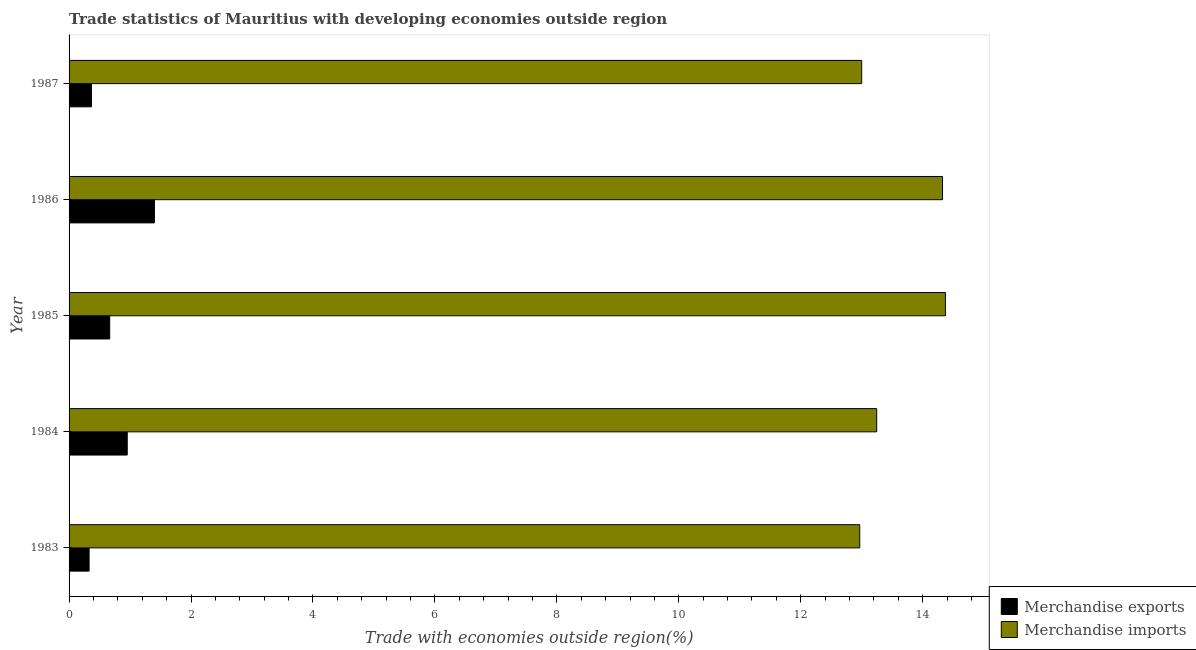How many different coloured bars are there?
Keep it short and to the point. 2. How many groups of bars are there?
Ensure brevity in your answer.  5. Are the number of bars per tick equal to the number of legend labels?
Make the answer very short. Yes. How many bars are there on the 4th tick from the top?
Offer a very short reply. 2. What is the label of the 2nd group of bars from the top?
Keep it short and to the point. 1986. What is the merchandise imports in 1987?
Offer a very short reply. 13. Across all years, what is the maximum merchandise imports?
Your response must be concise. 14.37. Across all years, what is the minimum merchandise imports?
Provide a succinct answer. 12.97. In which year was the merchandise imports maximum?
Ensure brevity in your answer.  1985. In which year was the merchandise exports minimum?
Your answer should be compact. 1983. What is the total merchandise imports in the graph?
Your answer should be very brief. 67.91. What is the difference between the merchandise imports in 1983 and that in 1985?
Your answer should be very brief. -1.41. What is the difference between the merchandise exports in 1987 and the merchandise imports in 1986?
Provide a succinct answer. -13.96. What is the average merchandise exports per year?
Provide a succinct answer. 0.74. In the year 1984, what is the difference between the merchandise imports and merchandise exports?
Your answer should be compact. 12.29. What is the ratio of the merchandise imports in 1985 to that in 1987?
Offer a very short reply. 1.11. Is the merchandise exports in 1986 less than that in 1987?
Provide a short and direct response. No. What is the difference between the highest and the second highest merchandise exports?
Offer a terse response. 0.45. What is the difference between the highest and the lowest merchandise exports?
Your answer should be compact. 1.07. Is the sum of the merchandise imports in 1984 and 1985 greater than the maximum merchandise exports across all years?
Provide a short and direct response. Yes. What does the 1st bar from the top in 1984 represents?
Your answer should be compact. Merchandise imports. Are all the bars in the graph horizontal?
Offer a very short reply. Yes. Are the values on the major ticks of X-axis written in scientific E-notation?
Provide a succinct answer. No. Does the graph contain grids?
Keep it short and to the point. No. How many legend labels are there?
Keep it short and to the point. 2. What is the title of the graph?
Offer a terse response. Trade statistics of Mauritius with developing economies outside region. Does "Non-resident workers" appear as one of the legend labels in the graph?
Your answer should be compact. No. What is the label or title of the X-axis?
Give a very brief answer. Trade with economies outside region(%). What is the label or title of the Y-axis?
Provide a succinct answer. Year. What is the Trade with economies outside region(%) in Merchandise exports in 1983?
Make the answer very short. 0.33. What is the Trade with economies outside region(%) in Merchandise imports in 1983?
Offer a very short reply. 12.97. What is the Trade with economies outside region(%) of Merchandise exports in 1984?
Make the answer very short. 0.95. What is the Trade with economies outside region(%) in Merchandise imports in 1984?
Give a very brief answer. 13.25. What is the Trade with economies outside region(%) of Merchandise exports in 1985?
Ensure brevity in your answer.  0.67. What is the Trade with economies outside region(%) of Merchandise imports in 1985?
Your answer should be compact. 14.37. What is the Trade with economies outside region(%) of Merchandise exports in 1986?
Ensure brevity in your answer.  1.4. What is the Trade with economies outside region(%) of Merchandise imports in 1986?
Give a very brief answer. 14.33. What is the Trade with economies outside region(%) of Merchandise exports in 1987?
Provide a short and direct response. 0.37. What is the Trade with economies outside region(%) in Merchandise imports in 1987?
Your response must be concise. 13. Across all years, what is the maximum Trade with economies outside region(%) of Merchandise exports?
Provide a short and direct response. 1.4. Across all years, what is the maximum Trade with economies outside region(%) of Merchandise imports?
Offer a very short reply. 14.37. Across all years, what is the minimum Trade with economies outside region(%) of Merchandise exports?
Make the answer very short. 0.33. Across all years, what is the minimum Trade with economies outside region(%) in Merchandise imports?
Keep it short and to the point. 12.97. What is the total Trade with economies outside region(%) in Merchandise exports in the graph?
Offer a very short reply. 3.72. What is the total Trade with economies outside region(%) of Merchandise imports in the graph?
Give a very brief answer. 67.91. What is the difference between the Trade with economies outside region(%) in Merchandise exports in 1983 and that in 1984?
Your answer should be compact. -0.63. What is the difference between the Trade with economies outside region(%) in Merchandise imports in 1983 and that in 1984?
Your answer should be very brief. -0.28. What is the difference between the Trade with economies outside region(%) in Merchandise exports in 1983 and that in 1985?
Provide a succinct answer. -0.34. What is the difference between the Trade with economies outside region(%) in Merchandise imports in 1983 and that in 1985?
Keep it short and to the point. -1.41. What is the difference between the Trade with economies outside region(%) of Merchandise exports in 1983 and that in 1986?
Provide a short and direct response. -1.07. What is the difference between the Trade with economies outside region(%) in Merchandise imports in 1983 and that in 1986?
Offer a very short reply. -1.36. What is the difference between the Trade with economies outside region(%) of Merchandise exports in 1983 and that in 1987?
Your answer should be very brief. -0.04. What is the difference between the Trade with economies outside region(%) in Merchandise imports in 1983 and that in 1987?
Your response must be concise. -0.03. What is the difference between the Trade with economies outside region(%) of Merchandise exports in 1984 and that in 1985?
Ensure brevity in your answer.  0.29. What is the difference between the Trade with economies outside region(%) in Merchandise imports in 1984 and that in 1985?
Provide a short and direct response. -1.13. What is the difference between the Trade with economies outside region(%) of Merchandise exports in 1984 and that in 1986?
Make the answer very short. -0.45. What is the difference between the Trade with economies outside region(%) of Merchandise imports in 1984 and that in 1986?
Your response must be concise. -1.08. What is the difference between the Trade with economies outside region(%) of Merchandise exports in 1984 and that in 1987?
Your answer should be very brief. 0.59. What is the difference between the Trade with economies outside region(%) in Merchandise imports in 1984 and that in 1987?
Your response must be concise. 0.25. What is the difference between the Trade with economies outside region(%) of Merchandise exports in 1985 and that in 1986?
Your response must be concise. -0.73. What is the difference between the Trade with economies outside region(%) in Merchandise imports in 1985 and that in 1986?
Your answer should be very brief. 0.05. What is the difference between the Trade with economies outside region(%) in Merchandise exports in 1985 and that in 1987?
Make the answer very short. 0.3. What is the difference between the Trade with economies outside region(%) in Merchandise imports in 1985 and that in 1987?
Provide a short and direct response. 1.37. What is the difference between the Trade with economies outside region(%) of Merchandise exports in 1986 and that in 1987?
Keep it short and to the point. 1.03. What is the difference between the Trade with economies outside region(%) in Merchandise imports in 1986 and that in 1987?
Provide a short and direct response. 1.33. What is the difference between the Trade with economies outside region(%) in Merchandise exports in 1983 and the Trade with economies outside region(%) in Merchandise imports in 1984?
Provide a succinct answer. -12.92. What is the difference between the Trade with economies outside region(%) of Merchandise exports in 1983 and the Trade with economies outside region(%) of Merchandise imports in 1985?
Keep it short and to the point. -14.05. What is the difference between the Trade with economies outside region(%) of Merchandise exports in 1983 and the Trade with economies outside region(%) of Merchandise imports in 1986?
Your response must be concise. -14. What is the difference between the Trade with economies outside region(%) of Merchandise exports in 1983 and the Trade with economies outside region(%) of Merchandise imports in 1987?
Provide a short and direct response. -12.67. What is the difference between the Trade with economies outside region(%) of Merchandise exports in 1984 and the Trade with economies outside region(%) of Merchandise imports in 1985?
Ensure brevity in your answer.  -13.42. What is the difference between the Trade with economies outside region(%) in Merchandise exports in 1984 and the Trade with economies outside region(%) in Merchandise imports in 1986?
Provide a succinct answer. -13.37. What is the difference between the Trade with economies outside region(%) of Merchandise exports in 1984 and the Trade with economies outside region(%) of Merchandise imports in 1987?
Keep it short and to the point. -12.05. What is the difference between the Trade with economies outside region(%) in Merchandise exports in 1985 and the Trade with economies outside region(%) in Merchandise imports in 1986?
Your response must be concise. -13.66. What is the difference between the Trade with economies outside region(%) in Merchandise exports in 1985 and the Trade with economies outside region(%) in Merchandise imports in 1987?
Ensure brevity in your answer.  -12.33. What is the difference between the Trade with economies outside region(%) of Merchandise exports in 1986 and the Trade with economies outside region(%) of Merchandise imports in 1987?
Provide a short and direct response. -11.6. What is the average Trade with economies outside region(%) of Merchandise exports per year?
Your response must be concise. 0.74. What is the average Trade with economies outside region(%) in Merchandise imports per year?
Offer a terse response. 13.58. In the year 1983, what is the difference between the Trade with economies outside region(%) of Merchandise exports and Trade with economies outside region(%) of Merchandise imports?
Make the answer very short. -12.64. In the year 1984, what is the difference between the Trade with economies outside region(%) of Merchandise exports and Trade with economies outside region(%) of Merchandise imports?
Provide a succinct answer. -12.29. In the year 1985, what is the difference between the Trade with economies outside region(%) in Merchandise exports and Trade with economies outside region(%) in Merchandise imports?
Provide a short and direct response. -13.71. In the year 1986, what is the difference between the Trade with economies outside region(%) in Merchandise exports and Trade with economies outside region(%) in Merchandise imports?
Keep it short and to the point. -12.93. In the year 1987, what is the difference between the Trade with economies outside region(%) of Merchandise exports and Trade with economies outside region(%) of Merchandise imports?
Give a very brief answer. -12.63. What is the ratio of the Trade with economies outside region(%) in Merchandise exports in 1983 to that in 1984?
Offer a terse response. 0.34. What is the ratio of the Trade with economies outside region(%) in Merchandise imports in 1983 to that in 1984?
Your answer should be compact. 0.98. What is the ratio of the Trade with economies outside region(%) of Merchandise exports in 1983 to that in 1985?
Keep it short and to the point. 0.49. What is the ratio of the Trade with economies outside region(%) of Merchandise imports in 1983 to that in 1985?
Offer a very short reply. 0.9. What is the ratio of the Trade with economies outside region(%) of Merchandise exports in 1983 to that in 1986?
Ensure brevity in your answer.  0.23. What is the ratio of the Trade with economies outside region(%) of Merchandise imports in 1983 to that in 1986?
Make the answer very short. 0.91. What is the ratio of the Trade with economies outside region(%) in Merchandise exports in 1983 to that in 1987?
Your response must be concise. 0.89. What is the ratio of the Trade with economies outside region(%) in Merchandise exports in 1984 to that in 1985?
Give a very brief answer. 1.43. What is the ratio of the Trade with economies outside region(%) in Merchandise imports in 1984 to that in 1985?
Offer a terse response. 0.92. What is the ratio of the Trade with economies outside region(%) in Merchandise exports in 1984 to that in 1986?
Provide a succinct answer. 0.68. What is the ratio of the Trade with economies outside region(%) of Merchandise imports in 1984 to that in 1986?
Make the answer very short. 0.92. What is the ratio of the Trade with economies outside region(%) in Merchandise exports in 1984 to that in 1987?
Your answer should be compact. 2.6. What is the ratio of the Trade with economies outside region(%) in Merchandise imports in 1984 to that in 1987?
Offer a very short reply. 1.02. What is the ratio of the Trade with economies outside region(%) in Merchandise exports in 1985 to that in 1986?
Give a very brief answer. 0.48. What is the ratio of the Trade with economies outside region(%) in Merchandise exports in 1985 to that in 1987?
Make the answer very short. 1.82. What is the ratio of the Trade with economies outside region(%) in Merchandise imports in 1985 to that in 1987?
Provide a short and direct response. 1.11. What is the ratio of the Trade with economies outside region(%) in Merchandise exports in 1986 to that in 1987?
Offer a very short reply. 3.82. What is the ratio of the Trade with economies outside region(%) in Merchandise imports in 1986 to that in 1987?
Offer a very short reply. 1.1. What is the difference between the highest and the second highest Trade with economies outside region(%) of Merchandise exports?
Your response must be concise. 0.45. What is the difference between the highest and the second highest Trade with economies outside region(%) of Merchandise imports?
Give a very brief answer. 0.05. What is the difference between the highest and the lowest Trade with economies outside region(%) of Merchandise exports?
Offer a very short reply. 1.07. What is the difference between the highest and the lowest Trade with economies outside region(%) of Merchandise imports?
Your answer should be compact. 1.41. 